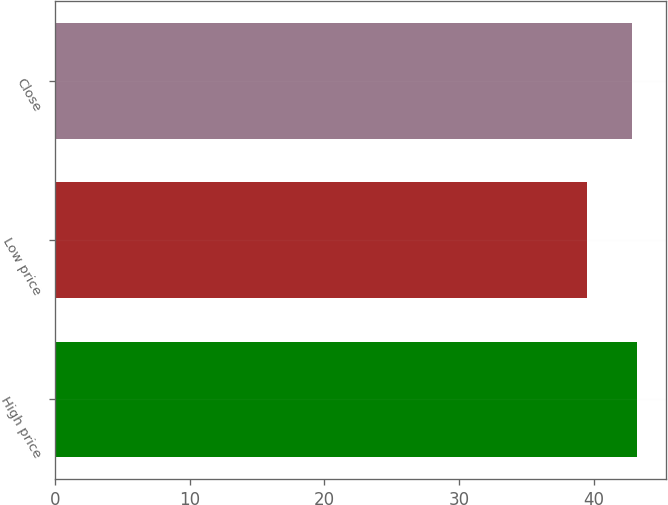<chart> <loc_0><loc_0><loc_500><loc_500><bar_chart><fcel>High price<fcel>Low price<fcel>Close<nl><fcel>43.18<fcel>39.53<fcel>42.84<nl></chart> 